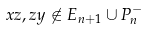<formula> <loc_0><loc_0><loc_500><loc_500>x z , z y \not \in E _ { n + 1 } \cup P ^ { - } _ { n }</formula> 